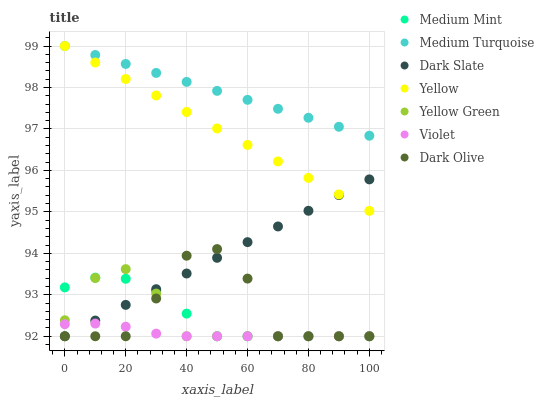Does Violet have the minimum area under the curve?
Answer yes or no. Yes. Does Medium Turquoise have the maximum area under the curve?
Answer yes or no. Yes. Does Yellow Green have the minimum area under the curve?
Answer yes or no. No. Does Yellow Green have the maximum area under the curve?
Answer yes or no. No. Is Dark Slate the smoothest?
Answer yes or no. Yes. Is Dark Olive the roughest?
Answer yes or no. Yes. Is Yellow Green the smoothest?
Answer yes or no. No. Is Yellow Green the roughest?
Answer yes or no. No. Does Medium Mint have the lowest value?
Answer yes or no. Yes. Does Yellow have the lowest value?
Answer yes or no. No. Does Medium Turquoise have the highest value?
Answer yes or no. Yes. Does Yellow Green have the highest value?
Answer yes or no. No. Is Medium Mint less than Yellow?
Answer yes or no. Yes. Is Medium Turquoise greater than Medium Mint?
Answer yes or no. Yes. Does Dark Olive intersect Violet?
Answer yes or no. Yes. Is Dark Olive less than Violet?
Answer yes or no. No. Is Dark Olive greater than Violet?
Answer yes or no. No. Does Medium Mint intersect Yellow?
Answer yes or no. No. 